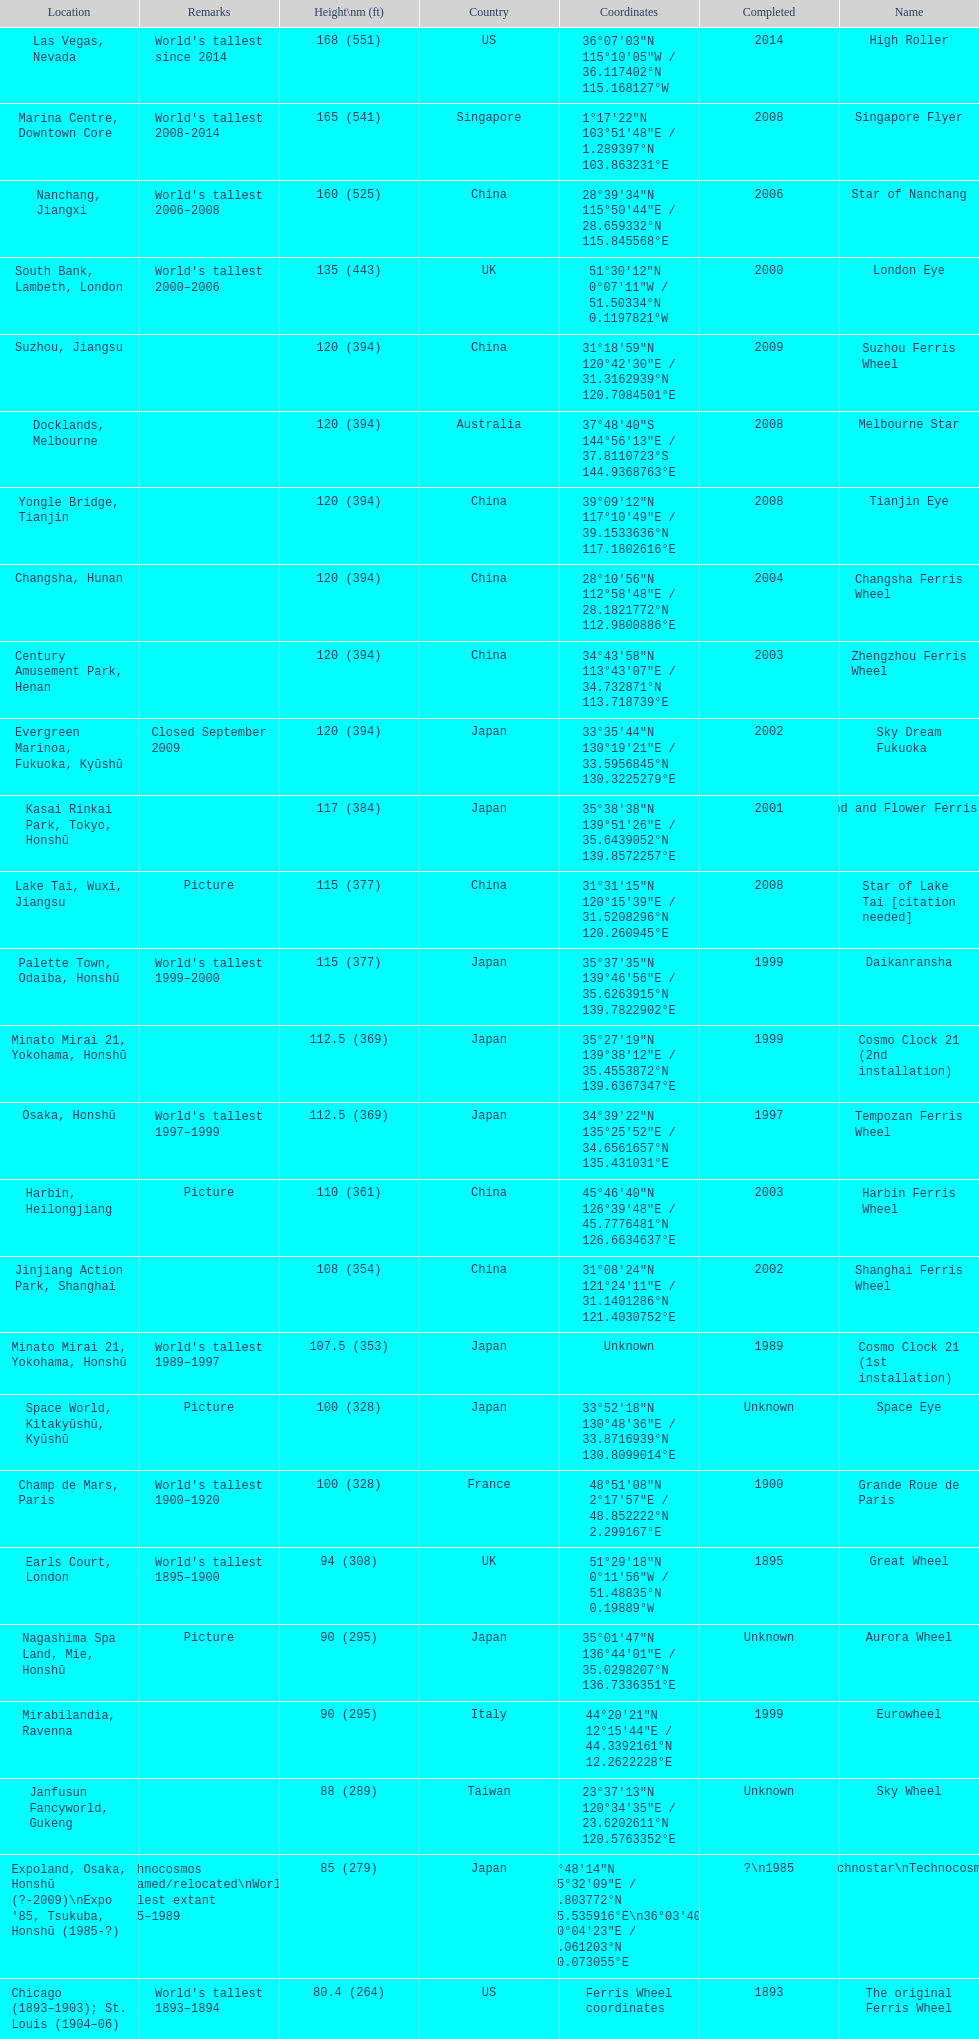What are all of the ferris wheels? High Roller, Singapore Flyer, Star of Nanchang, London Eye, Suzhou Ferris Wheel, Melbourne Star, Tianjin Eye, Changsha Ferris Wheel, Zhengzhou Ferris Wheel, Sky Dream Fukuoka, Diamond and Flower Ferris Wheel, Star of Lake Tai [citation needed], Daikanransha, Cosmo Clock 21 (2nd installation), Tempozan Ferris Wheel, Harbin Ferris Wheel, Shanghai Ferris Wheel, Cosmo Clock 21 (1st installation), Space Eye, Grande Roue de Paris, Great Wheel, Aurora Wheel, Eurowheel, Sky Wheel, Technostar\nTechnocosmos, The original Ferris Wheel. And when were they completed? 2014, 2008, 2006, 2000, 2009, 2008, 2008, 2004, 2003, 2002, 2001, 2008, 1999, 1999, 1997, 2003, 2002, 1989, Unknown, 1900, 1895, Unknown, 1999, Unknown, ?\n1985, 1893. And among star of lake tai, star of nanchang, and melbourne star, which ferris wheel is oldest? Star of Nanchang. 